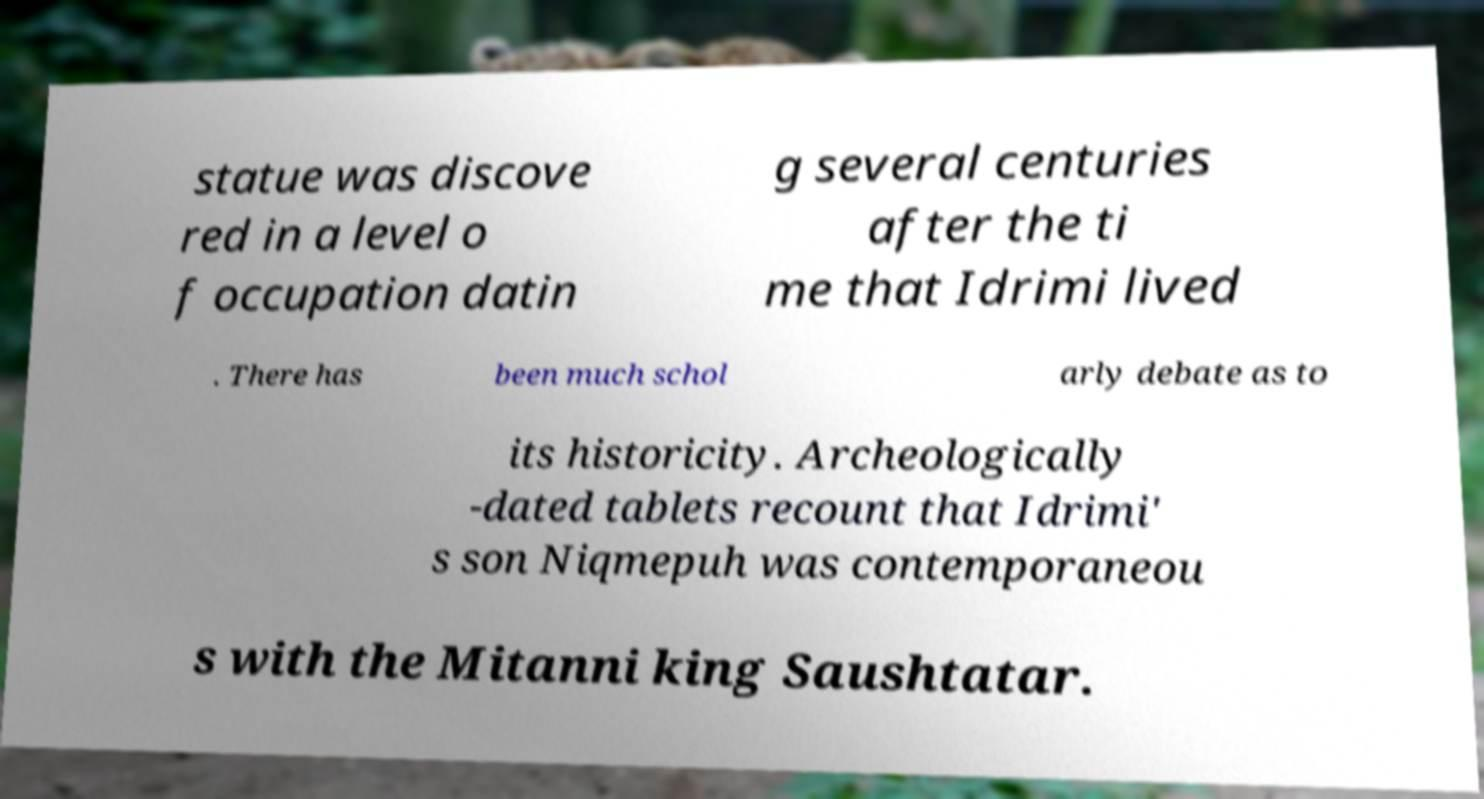I need the written content from this picture converted into text. Can you do that? statue was discove red in a level o f occupation datin g several centuries after the ti me that Idrimi lived . There has been much schol arly debate as to its historicity. Archeologically -dated tablets recount that Idrimi' s son Niqmepuh was contemporaneou s with the Mitanni king Saushtatar. 